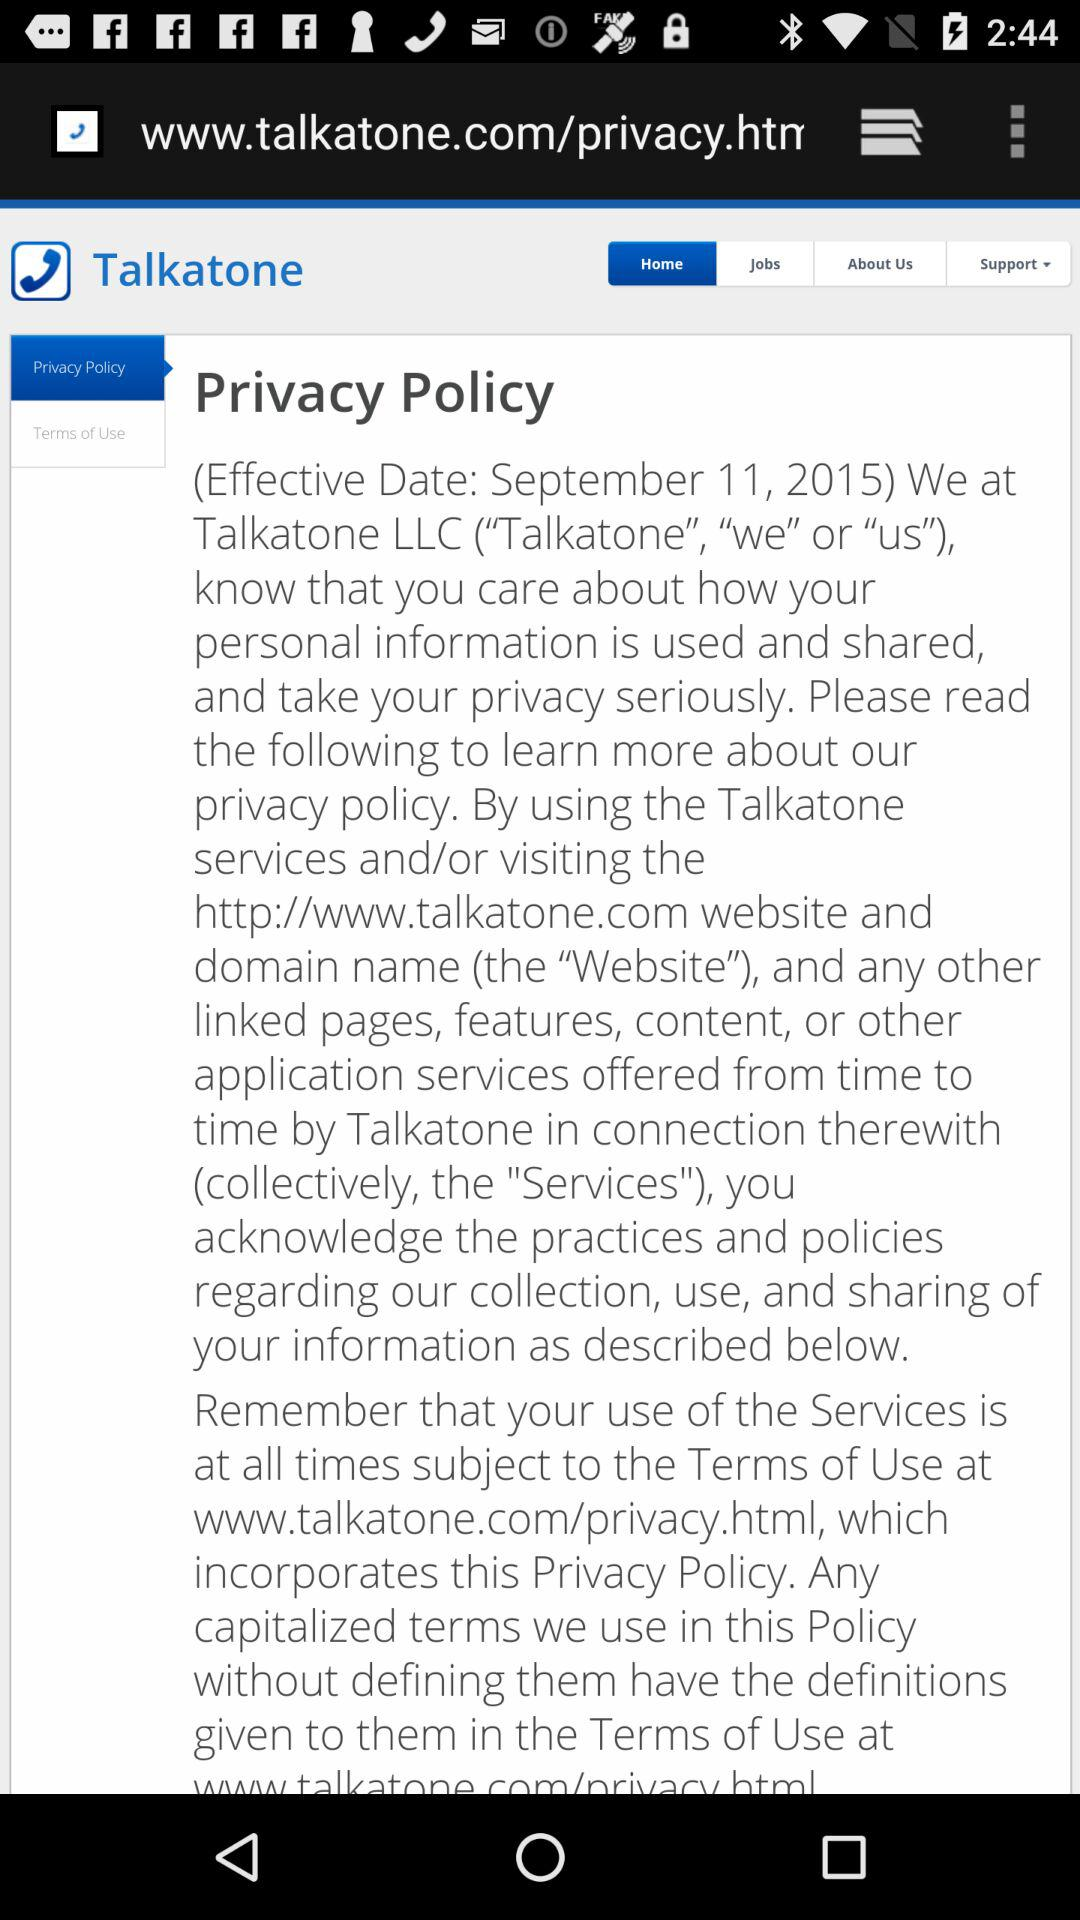What is the effective date of "Privacy Policy"? The effective date of "Privacy Policy" is September 11, 2015. 